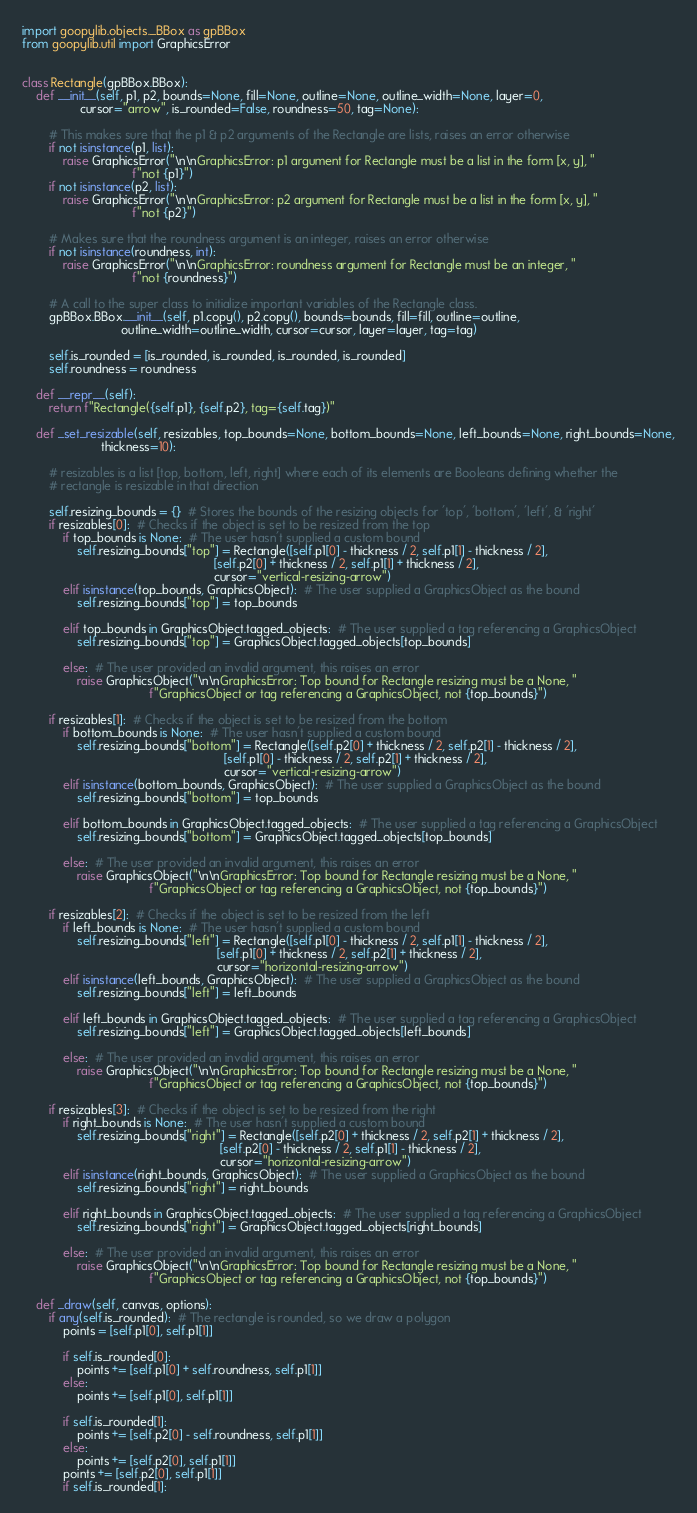Convert code to text. <code><loc_0><loc_0><loc_500><loc_500><_Python_>import goopylib.objects._BBox as gpBBox
from goopylib.util import GraphicsError


class Rectangle(gpBBox.BBox):
    def __init__(self, p1, p2, bounds=None, fill=None, outline=None, outline_width=None, layer=0,
                 cursor="arrow", is_rounded=False, roundness=50, tag=None):

        # This makes sure that the p1 & p2 arguments of the Rectangle are lists, raises an error otherwise
        if not isinstance(p1, list):
            raise GraphicsError("\n\nGraphicsError: p1 argument for Rectangle must be a list in the form [x, y], "
                                f"not {p1}")
        if not isinstance(p2, list):
            raise GraphicsError("\n\nGraphicsError: p2 argument for Rectangle must be a list in the form [x, y], "
                                f"not {p2}")

        # Makes sure that the roundness argument is an integer, raises an error otherwise
        if not isinstance(roundness, int):
            raise GraphicsError("\n\nGraphicsError: roundness argument for Rectangle must be an integer, "
                                f"not {roundness}")

        # A call to the super class to initialize important variables of the Rectangle class.
        gpBBox.BBox.__init__(self, p1.copy(), p2.copy(), bounds=bounds, fill=fill, outline=outline,
                             outline_width=outline_width, cursor=cursor, layer=layer, tag=tag)

        self.is_rounded = [is_rounded, is_rounded, is_rounded, is_rounded]
        self.roundness = roundness

    def __repr__(self):
        return f"Rectangle({self.p1}, {self.p2}, tag={self.tag})"

    def _set_resizable(self, resizables, top_bounds=None, bottom_bounds=None, left_bounds=None, right_bounds=None,
                       thickness=10):

        # resizables is a list [top, bottom, left, right] where each of its elements are Booleans defining whether the
        # rectangle is resizable in that direction

        self.resizing_bounds = {}  # Stores the bounds of the resizing objects for 'top', 'bottom', 'left', & 'right'
        if resizables[0]:  # Checks if the object is set to be resized from the top
            if top_bounds is None:  # The user hasn't supplied a custom bound
                self.resizing_bounds["top"] = Rectangle([self.p1[0] - thickness / 2, self.p1[1] - thickness / 2],
                                                        [self.p2[0] + thickness / 2, self.p1[1] + thickness / 2],
                                                        cursor="vertical-resizing-arrow")
            elif isinstance(top_bounds, GraphicsObject):  # The user supplied a GraphicsObject as the bound
                self.resizing_bounds["top"] = top_bounds

            elif top_bounds in GraphicsObject.tagged_objects:  # The user supplied a tag referencing a GraphicsObject
                self.resizing_bounds["top"] = GraphicsObject.tagged_objects[top_bounds]

            else:  # The user provided an invalid argument, this raises an error
                raise GraphicsObject("\n\nGraphicsError: Top bound for Rectangle resizing must be a None, "
                                     f"GraphicsObject or tag referencing a GraphicsObject, not {top_bounds}")

        if resizables[1]:  # Checks if the object is set to be resized from the bottom
            if bottom_bounds is None:  # The user hasn't supplied a custom bound
                self.resizing_bounds["bottom"] = Rectangle([self.p2[0] + thickness / 2, self.p2[1] - thickness / 2],
                                                           [self.p1[0] - thickness / 2, self.p2[1] + thickness / 2],
                                                           cursor="vertical-resizing-arrow")
            elif isinstance(bottom_bounds, GraphicsObject):  # The user supplied a GraphicsObject as the bound
                self.resizing_bounds["bottom"] = top_bounds

            elif bottom_bounds in GraphicsObject.tagged_objects:  # The user supplied a tag referencing a GraphicsObject
                self.resizing_bounds["bottom"] = GraphicsObject.tagged_objects[top_bounds]

            else:  # The user provided an invalid argument, this raises an error
                raise GraphicsObject("\n\nGraphicsError: Top bound for Rectangle resizing must be a None, "
                                     f"GraphicsObject or tag referencing a GraphicsObject, not {top_bounds}")

        if resizables[2]:  # Checks if the object is set to be resized from the left
            if left_bounds is None:  # The user hasn't supplied a custom bound
                self.resizing_bounds["left"] = Rectangle([self.p1[0] - thickness / 2, self.p1[1] - thickness / 2],
                                                         [self.p1[0] + thickness / 2, self.p2[1] + thickness / 2],
                                                         cursor="horizontal-resizing-arrow")
            elif isinstance(left_bounds, GraphicsObject):  # The user supplied a GraphicsObject as the bound
                self.resizing_bounds["left"] = left_bounds

            elif left_bounds in GraphicsObject.tagged_objects:  # The user supplied a tag referencing a GraphicsObject
                self.resizing_bounds["left"] = GraphicsObject.tagged_objects[left_bounds]

            else:  # The user provided an invalid argument, this raises an error
                raise GraphicsObject("\n\nGraphicsError: Top bound for Rectangle resizing must be a None, "
                                     f"GraphicsObject or tag referencing a GraphicsObject, not {top_bounds}")

        if resizables[3]:  # Checks if the object is set to be resized from the right
            if right_bounds is None:  # The user hasn't supplied a custom bound
                self.resizing_bounds["right"] = Rectangle([self.p2[0] + thickness / 2, self.p2[1] + thickness / 2],
                                                          [self.p2[0] - thickness / 2, self.p1[1] - thickness / 2],
                                                          cursor="horizontal-resizing-arrow")
            elif isinstance(right_bounds, GraphicsObject):  # The user supplied a GraphicsObject as the bound
                self.resizing_bounds["right"] = right_bounds

            elif right_bounds in GraphicsObject.tagged_objects:  # The user supplied a tag referencing a GraphicsObject
                self.resizing_bounds["right"] = GraphicsObject.tagged_objects[right_bounds]

            else:  # The user provided an invalid argument, this raises an error
                raise GraphicsObject("\n\nGraphicsError: Top bound for Rectangle resizing must be a None, "
                                     f"GraphicsObject or tag referencing a GraphicsObject, not {top_bounds}")

    def _draw(self, canvas, options):
        if any(self.is_rounded):  # The rectangle is rounded, so we draw a polygon
            points = [self.p1[0], self.p1[1]]

            if self.is_rounded[0]:
                points += [self.p1[0] + self.roundness, self.p1[1]]
            else:
                points += [self.p1[0], self.p1[1]]

            if self.is_rounded[1]:
                points += [self.p2[0] - self.roundness, self.p1[1]]
            else:
                points += [self.p2[0], self.p1[1]]
            points += [self.p2[0], self.p1[1]]
            if self.is_rounded[1]:</code> 